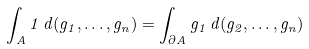<formula> <loc_0><loc_0><loc_500><loc_500>\int _ { A } 1 \, d ( g _ { 1 } , \dots , g _ { n } ) = \int _ { \partial A } g _ { 1 } \, d ( g _ { 2 } , \dots , g _ { n } )</formula> 